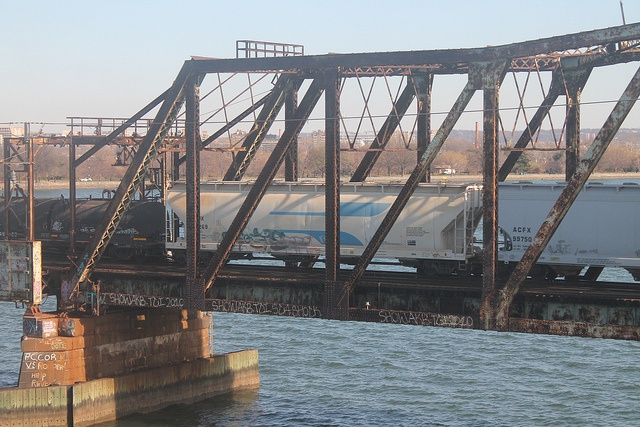Describe the objects in this image and their specific colors. I can see a train in lightblue and gray tones in this image. 